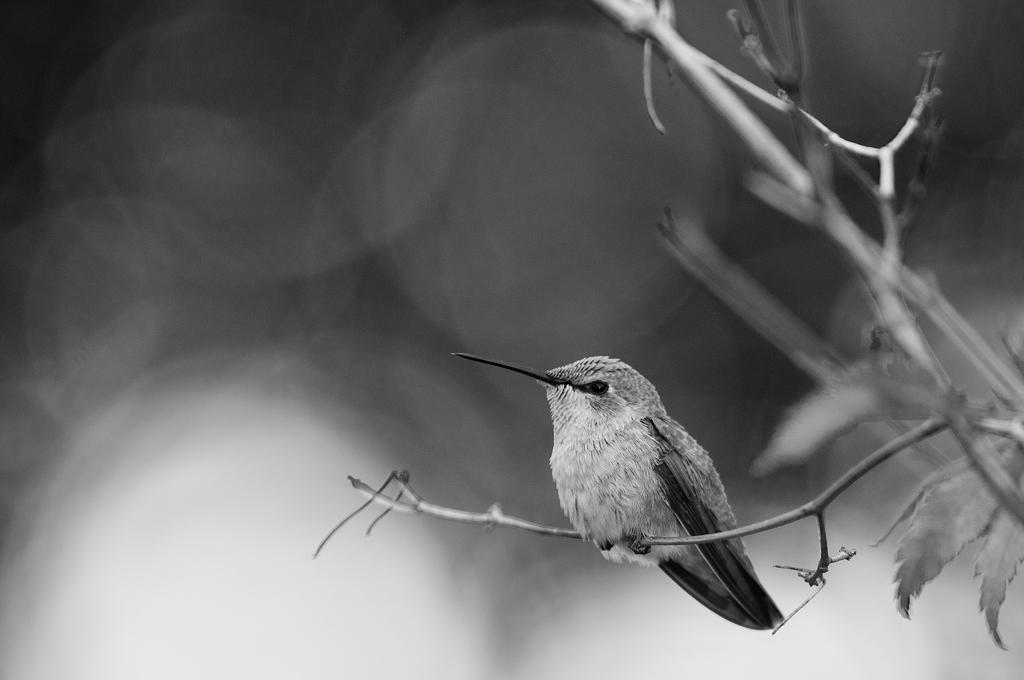What type of animal can be seen in the image? There is a bird in the image. Where is the bird located? The bird is on a small plant. What is the appearance of the bird's beak? The bird has a sharp beak. How would you describe the background of the image? The background of the image is blurred. What color scheme is used in the image? The image is black and white. What type of cord is being used by the judge in the image? There is no judge or cord present in the image; it features a bird on a small plant in a black and white, blurred background. 